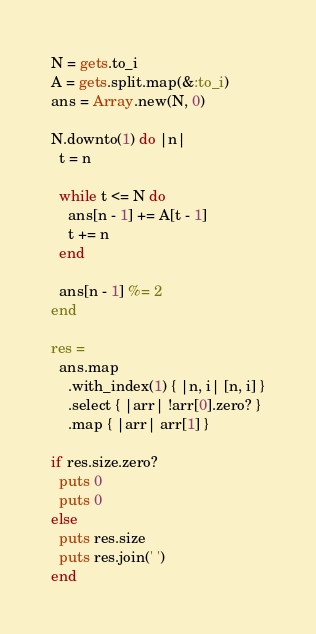Convert code to text. <code><loc_0><loc_0><loc_500><loc_500><_Ruby_>N = gets.to_i
A = gets.split.map(&:to_i)
ans = Array.new(N, 0)

N.downto(1) do |n|
  t = n

  while t <= N do
    ans[n - 1] += A[t - 1]
    t += n
  end

  ans[n - 1] %= 2
end

res =
  ans.map
    .with_index(1) { |n, i| [n, i] }
    .select { |arr| !arr[0].zero? }
    .map { |arr| arr[1] }

if res.size.zero?
  puts 0
  puts 0
else
  puts res.size
  puts res.join(' ')
end</code> 